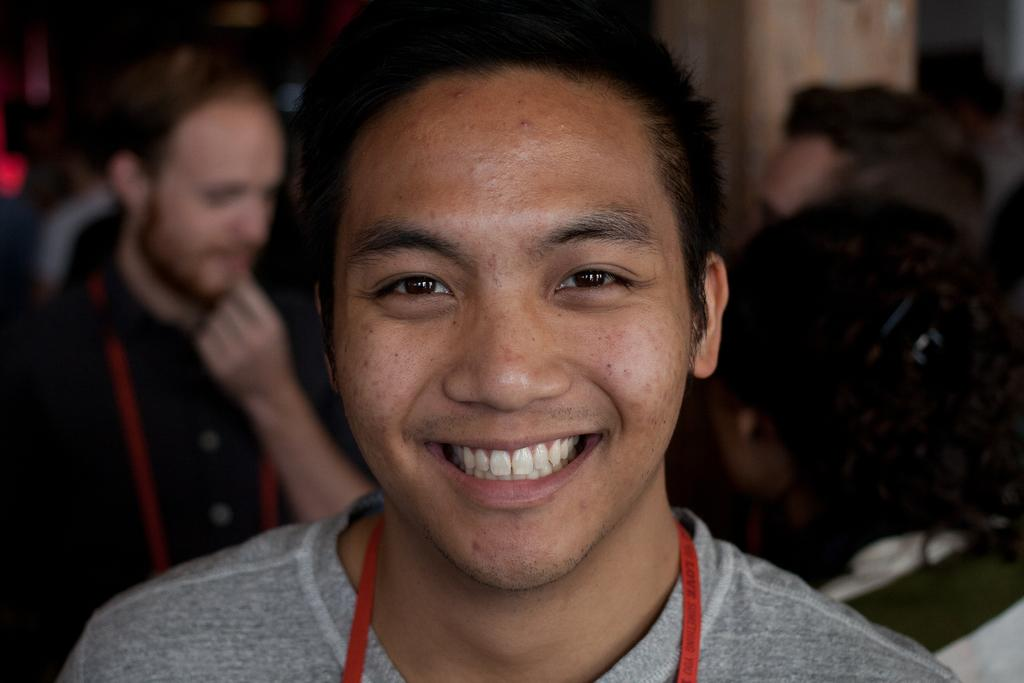Who is present in the image? There is a person in the image. What is the person doing in the image? The person is smiling. What is the person wearing in the image? The person is wearing a grey t-shirt. Can you describe the surroundings of the person in the image? There are other persons in the background of the image. What type of meat is being transported by the person in the image? There is no meat or transportation activity present in the image; it features a person smiling and wearing a grey t-shirt. 